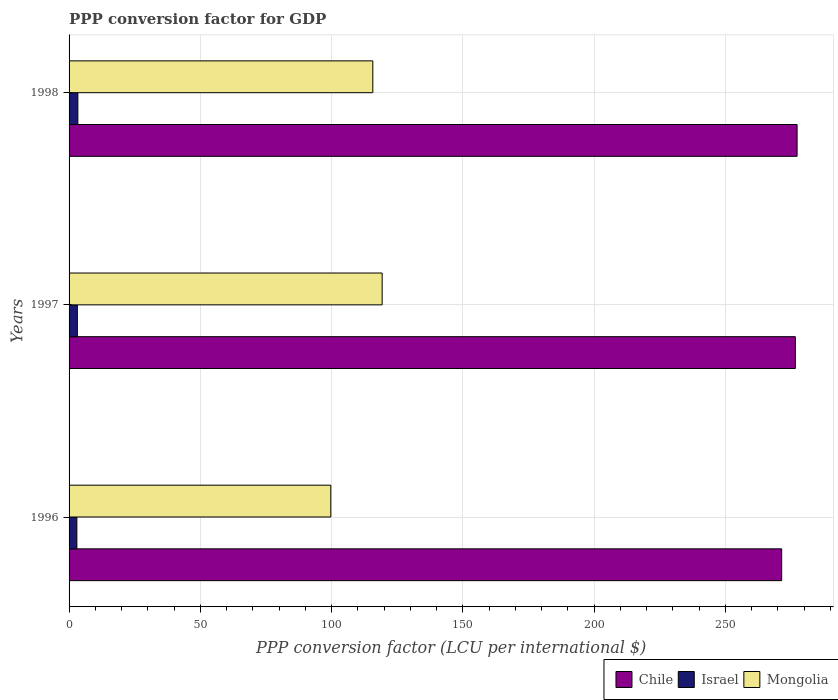How many bars are there on the 2nd tick from the top?
Offer a terse response. 3. In how many cases, is the number of bars for a given year not equal to the number of legend labels?
Your response must be concise. 0. What is the PPP conversion factor for GDP in Mongolia in 1998?
Offer a terse response. 115.71. Across all years, what is the maximum PPP conversion factor for GDP in Mongolia?
Offer a terse response. 119.27. Across all years, what is the minimum PPP conversion factor for GDP in Mongolia?
Your answer should be compact. 99.7. In which year was the PPP conversion factor for GDP in Mongolia maximum?
Give a very brief answer. 1997. What is the total PPP conversion factor for GDP in Israel in the graph?
Ensure brevity in your answer.  9.48. What is the difference between the PPP conversion factor for GDP in Israel in 1996 and that in 1997?
Provide a short and direct response. -0.19. What is the difference between the PPP conversion factor for GDP in Israel in 1996 and the PPP conversion factor for GDP in Chile in 1997?
Your answer should be very brief. -273.7. What is the average PPP conversion factor for GDP in Mongolia per year?
Ensure brevity in your answer.  111.56. In the year 1997, what is the difference between the PPP conversion factor for GDP in Chile and PPP conversion factor for GDP in Mongolia?
Provide a succinct answer. 157.41. In how many years, is the PPP conversion factor for GDP in Mongolia greater than 190 LCU?
Give a very brief answer. 0. What is the ratio of the PPP conversion factor for GDP in Chile in 1997 to that in 1998?
Offer a very short reply. 1. Is the PPP conversion factor for GDP in Chile in 1996 less than that in 1997?
Keep it short and to the point. Yes. What is the difference between the highest and the second highest PPP conversion factor for GDP in Israel?
Provide a short and direct response. 0.19. What is the difference between the highest and the lowest PPP conversion factor for GDP in Chile?
Provide a short and direct response. 5.87. Is the sum of the PPP conversion factor for GDP in Mongolia in 1996 and 1997 greater than the maximum PPP conversion factor for GDP in Israel across all years?
Give a very brief answer. Yes. What does the 1st bar from the top in 1998 represents?
Provide a succinct answer. Mongolia. What does the 3rd bar from the bottom in 1996 represents?
Your response must be concise. Mongolia. How many years are there in the graph?
Offer a very short reply. 3. Are the values on the major ticks of X-axis written in scientific E-notation?
Your response must be concise. No. Does the graph contain any zero values?
Your response must be concise. No. Does the graph contain grids?
Offer a very short reply. Yes. What is the title of the graph?
Offer a terse response. PPP conversion factor for GDP. What is the label or title of the X-axis?
Give a very brief answer. PPP conversion factor (LCU per international $). What is the label or title of the Y-axis?
Your response must be concise. Years. What is the PPP conversion factor (LCU per international $) of Chile in 1996?
Ensure brevity in your answer.  271.46. What is the PPP conversion factor (LCU per international $) in Israel in 1996?
Offer a terse response. 2.97. What is the PPP conversion factor (LCU per international $) of Mongolia in 1996?
Offer a terse response. 99.7. What is the PPP conversion factor (LCU per international $) in Chile in 1997?
Provide a short and direct response. 276.67. What is the PPP conversion factor (LCU per international $) of Israel in 1997?
Offer a terse response. 3.16. What is the PPP conversion factor (LCU per international $) in Mongolia in 1997?
Provide a short and direct response. 119.27. What is the PPP conversion factor (LCU per international $) in Chile in 1998?
Offer a terse response. 277.33. What is the PPP conversion factor (LCU per international $) in Israel in 1998?
Your response must be concise. 3.35. What is the PPP conversion factor (LCU per international $) in Mongolia in 1998?
Offer a very short reply. 115.71. Across all years, what is the maximum PPP conversion factor (LCU per international $) in Chile?
Provide a short and direct response. 277.33. Across all years, what is the maximum PPP conversion factor (LCU per international $) of Israel?
Give a very brief answer. 3.35. Across all years, what is the maximum PPP conversion factor (LCU per international $) of Mongolia?
Provide a succinct answer. 119.27. Across all years, what is the minimum PPP conversion factor (LCU per international $) of Chile?
Your response must be concise. 271.46. Across all years, what is the minimum PPP conversion factor (LCU per international $) in Israel?
Keep it short and to the point. 2.97. Across all years, what is the minimum PPP conversion factor (LCU per international $) of Mongolia?
Your response must be concise. 99.7. What is the total PPP conversion factor (LCU per international $) in Chile in the graph?
Provide a short and direct response. 825.47. What is the total PPP conversion factor (LCU per international $) of Israel in the graph?
Your answer should be compact. 9.48. What is the total PPP conversion factor (LCU per international $) of Mongolia in the graph?
Provide a short and direct response. 334.67. What is the difference between the PPP conversion factor (LCU per international $) in Chile in 1996 and that in 1997?
Keep it short and to the point. -5.21. What is the difference between the PPP conversion factor (LCU per international $) in Israel in 1996 and that in 1997?
Your answer should be compact. -0.19. What is the difference between the PPP conversion factor (LCU per international $) in Mongolia in 1996 and that in 1997?
Your answer should be compact. -19.57. What is the difference between the PPP conversion factor (LCU per international $) of Chile in 1996 and that in 1998?
Provide a short and direct response. -5.87. What is the difference between the PPP conversion factor (LCU per international $) of Israel in 1996 and that in 1998?
Provide a short and direct response. -0.37. What is the difference between the PPP conversion factor (LCU per international $) of Mongolia in 1996 and that in 1998?
Offer a terse response. -16.01. What is the difference between the PPP conversion factor (LCU per international $) of Chile in 1997 and that in 1998?
Your answer should be very brief. -0.66. What is the difference between the PPP conversion factor (LCU per international $) in Israel in 1997 and that in 1998?
Your answer should be very brief. -0.19. What is the difference between the PPP conversion factor (LCU per international $) of Mongolia in 1997 and that in 1998?
Provide a succinct answer. 3.56. What is the difference between the PPP conversion factor (LCU per international $) in Chile in 1996 and the PPP conversion factor (LCU per international $) in Israel in 1997?
Keep it short and to the point. 268.3. What is the difference between the PPP conversion factor (LCU per international $) in Chile in 1996 and the PPP conversion factor (LCU per international $) in Mongolia in 1997?
Your answer should be compact. 152.2. What is the difference between the PPP conversion factor (LCU per international $) in Israel in 1996 and the PPP conversion factor (LCU per international $) in Mongolia in 1997?
Keep it short and to the point. -116.29. What is the difference between the PPP conversion factor (LCU per international $) of Chile in 1996 and the PPP conversion factor (LCU per international $) of Israel in 1998?
Your response must be concise. 268.11. What is the difference between the PPP conversion factor (LCU per international $) in Chile in 1996 and the PPP conversion factor (LCU per international $) in Mongolia in 1998?
Your response must be concise. 155.76. What is the difference between the PPP conversion factor (LCU per international $) of Israel in 1996 and the PPP conversion factor (LCU per international $) of Mongolia in 1998?
Your answer should be compact. -112.73. What is the difference between the PPP conversion factor (LCU per international $) of Chile in 1997 and the PPP conversion factor (LCU per international $) of Israel in 1998?
Offer a very short reply. 273.32. What is the difference between the PPP conversion factor (LCU per international $) of Chile in 1997 and the PPP conversion factor (LCU per international $) of Mongolia in 1998?
Provide a succinct answer. 160.97. What is the difference between the PPP conversion factor (LCU per international $) of Israel in 1997 and the PPP conversion factor (LCU per international $) of Mongolia in 1998?
Keep it short and to the point. -112.55. What is the average PPP conversion factor (LCU per international $) of Chile per year?
Your response must be concise. 275.16. What is the average PPP conversion factor (LCU per international $) in Israel per year?
Offer a very short reply. 3.16. What is the average PPP conversion factor (LCU per international $) of Mongolia per year?
Your answer should be very brief. 111.56. In the year 1996, what is the difference between the PPP conversion factor (LCU per international $) in Chile and PPP conversion factor (LCU per international $) in Israel?
Provide a short and direct response. 268.49. In the year 1996, what is the difference between the PPP conversion factor (LCU per international $) of Chile and PPP conversion factor (LCU per international $) of Mongolia?
Provide a succinct answer. 171.76. In the year 1996, what is the difference between the PPP conversion factor (LCU per international $) in Israel and PPP conversion factor (LCU per international $) in Mongolia?
Give a very brief answer. -96.72. In the year 1997, what is the difference between the PPP conversion factor (LCU per international $) of Chile and PPP conversion factor (LCU per international $) of Israel?
Provide a succinct answer. 273.51. In the year 1997, what is the difference between the PPP conversion factor (LCU per international $) of Chile and PPP conversion factor (LCU per international $) of Mongolia?
Make the answer very short. 157.41. In the year 1997, what is the difference between the PPP conversion factor (LCU per international $) of Israel and PPP conversion factor (LCU per international $) of Mongolia?
Give a very brief answer. -116.11. In the year 1998, what is the difference between the PPP conversion factor (LCU per international $) of Chile and PPP conversion factor (LCU per international $) of Israel?
Your answer should be compact. 273.98. In the year 1998, what is the difference between the PPP conversion factor (LCU per international $) in Chile and PPP conversion factor (LCU per international $) in Mongolia?
Your answer should be very brief. 161.63. In the year 1998, what is the difference between the PPP conversion factor (LCU per international $) of Israel and PPP conversion factor (LCU per international $) of Mongolia?
Provide a short and direct response. -112.36. What is the ratio of the PPP conversion factor (LCU per international $) in Chile in 1996 to that in 1997?
Provide a succinct answer. 0.98. What is the ratio of the PPP conversion factor (LCU per international $) of Israel in 1996 to that in 1997?
Ensure brevity in your answer.  0.94. What is the ratio of the PPP conversion factor (LCU per international $) in Mongolia in 1996 to that in 1997?
Your answer should be very brief. 0.84. What is the ratio of the PPP conversion factor (LCU per international $) in Chile in 1996 to that in 1998?
Provide a succinct answer. 0.98. What is the ratio of the PPP conversion factor (LCU per international $) in Israel in 1996 to that in 1998?
Provide a succinct answer. 0.89. What is the ratio of the PPP conversion factor (LCU per international $) of Mongolia in 1996 to that in 1998?
Your answer should be compact. 0.86. What is the ratio of the PPP conversion factor (LCU per international $) in Chile in 1997 to that in 1998?
Give a very brief answer. 1. What is the ratio of the PPP conversion factor (LCU per international $) of Israel in 1997 to that in 1998?
Ensure brevity in your answer.  0.94. What is the ratio of the PPP conversion factor (LCU per international $) in Mongolia in 1997 to that in 1998?
Your response must be concise. 1.03. What is the difference between the highest and the second highest PPP conversion factor (LCU per international $) of Chile?
Offer a terse response. 0.66. What is the difference between the highest and the second highest PPP conversion factor (LCU per international $) in Israel?
Offer a terse response. 0.19. What is the difference between the highest and the second highest PPP conversion factor (LCU per international $) in Mongolia?
Offer a terse response. 3.56. What is the difference between the highest and the lowest PPP conversion factor (LCU per international $) of Chile?
Provide a short and direct response. 5.87. What is the difference between the highest and the lowest PPP conversion factor (LCU per international $) of Israel?
Your response must be concise. 0.37. What is the difference between the highest and the lowest PPP conversion factor (LCU per international $) of Mongolia?
Provide a short and direct response. 19.57. 